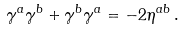Convert formula to latex. <formula><loc_0><loc_0><loc_500><loc_500>\gamma ^ { a } \gamma ^ { b } + \gamma ^ { b } \gamma ^ { a } = - 2 \eta ^ { a b } \, .</formula> 